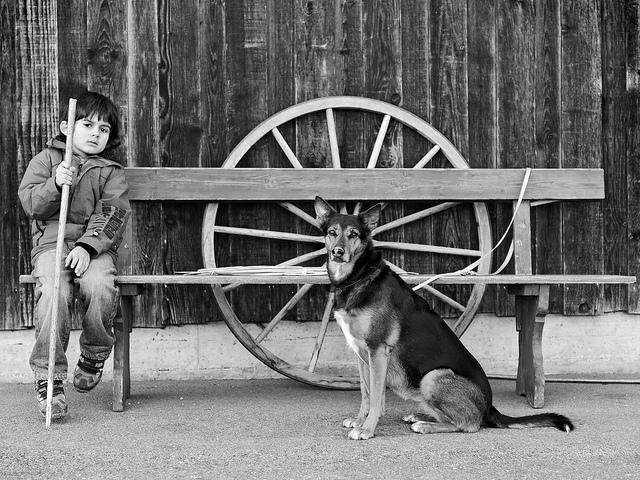What is the wheel called that's behind the bench?

Choices:
A) train wheels
B) chariot wheels
C) artillery wheels
D) wagon wheel wagon wheel 